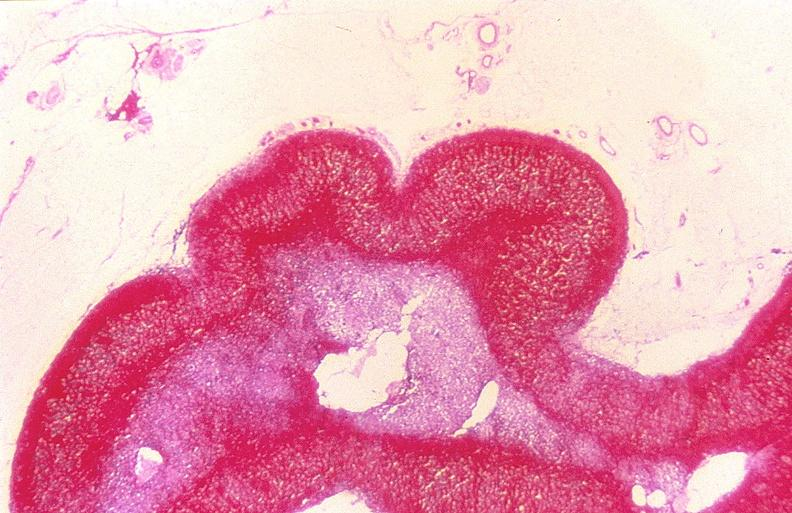s endocrine present?
Answer the question using a single word or phrase. Yes 